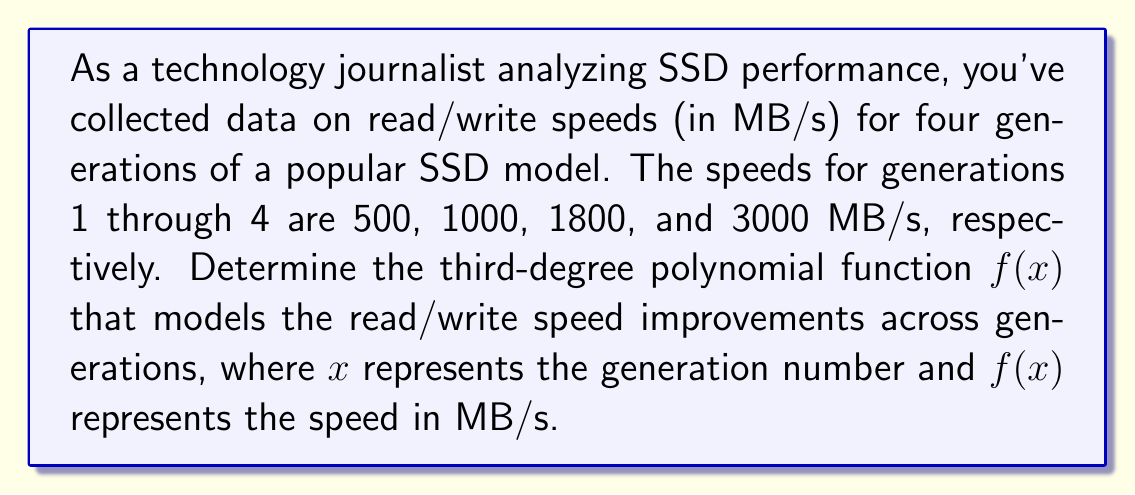Can you solve this math problem? To find the third-degree polynomial function $f(x) = ax^3 + bx^2 + cx + d$ that fits the given data points, we'll use the method of finite differences:

1. Set up the data points:
   $(1, 500)$, $(2, 1000)$, $(3, 1800)$, $(4, 3000)$

2. Calculate the first differences:
   $1000 - 500 = 500$
   $1800 - 1000 = 800$
   $3000 - 1800 = 1200$

3. Calculate the second differences:
   $800 - 500 = 300$
   $1200 - 800 = 400$

4. Calculate the third difference:
   $400 - 300 = 100$

5. Since the third difference is constant, we can determine the coefficients:
   $a = \frac{100}{3!} = \frac{100}{6} = \frac{50}{3}$
   $b = \frac{300 - 3a}{2} = \frac{300 - 50}{2} = 125$
   $c = 500 - a - b = 500 - \frac{50}{3} - 125 = \frac{1075}{3}$
   $d = 500$ (the y-intercept)

6. Construct the polynomial function:
   $f(x) = \frac{50}{3}x^3 + 125x^2 + \frac{1075}{3}x + 500$

7. Verify the function by testing it with the given data points:
   $f(1) = \frac{50}{3} + 125 + \frac{1075}{3} + 500 = 500$
   $f(2) = 400 + 500 + \frac{2150}{3} + 500 = 1000$
   $f(3) = 1350 + 1125 + 1075 + 500 = 1800$
   $f(4) = 3200 + 2000 + \frac{4300}{3} + 500 = 3000$

The function correctly models the given data points.
Answer: $f(x) = \frac{50}{3}x^3 + 125x^2 + \frac{1075}{3}x + 500$ 